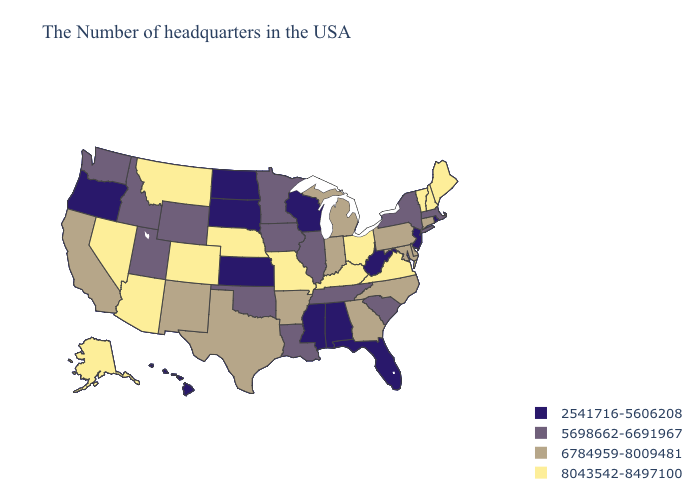Name the states that have a value in the range 2541716-5606208?
Be succinct. Rhode Island, New Jersey, West Virginia, Florida, Alabama, Wisconsin, Mississippi, Kansas, South Dakota, North Dakota, Oregon, Hawaii. Which states have the lowest value in the South?
Give a very brief answer. West Virginia, Florida, Alabama, Mississippi. Among the states that border Kansas , does Oklahoma have the highest value?
Write a very short answer. No. Name the states that have a value in the range 5698662-6691967?
Quick response, please. Massachusetts, New York, South Carolina, Tennessee, Illinois, Louisiana, Minnesota, Iowa, Oklahoma, Wyoming, Utah, Idaho, Washington. Name the states that have a value in the range 2541716-5606208?
Concise answer only. Rhode Island, New Jersey, West Virginia, Florida, Alabama, Wisconsin, Mississippi, Kansas, South Dakota, North Dakota, Oregon, Hawaii. Name the states that have a value in the range 2541716-5606208?
Short answer required. Rhode Island, New Jersey, West Virginia, Florida, Alabama, Wisconsin, Mississippi, Kansas, South Dakota, North Dakota, Oregon, Hawaii. Which states have the lowest value in the MidWest?
Be succinct. Wisconsin, Kansas, South Dakota, North Dakota. Does the map have missing data?
Answer briefly. No. Does Kansas have the highest value in the USA?
Write a very short answer. No. Does Georgia have the highest value in the USA?
Short answer required. No. Name the states that have a value in the range 8043542-8497100?
Write a very short answer. Maine, New Hampshire, Vermont, Virginia, Ohio, Kentucky, Missouri, Nebraska, Colorado, Montana, Arizona, Nevada, Alaska. Name the states that have a value in the range 8043542-8497100?
Write a very short answer. Maine, New Hampshire, Vermont, Virginia, Ohio, Kentucky, Missouri, Nebraska, Colorado, Montana, Arizona, Nevada, Alaska. Among the states that border New Mexico , which have the highest value?
Answer briefly. Colorado, Arizona. Which states hav the highest value in the MidWest?
Quick response, please. Ohio, Missouri, Nebraska. What is the lowest value in states that border Kansas?
Be succinct. 5698662-6691967. 